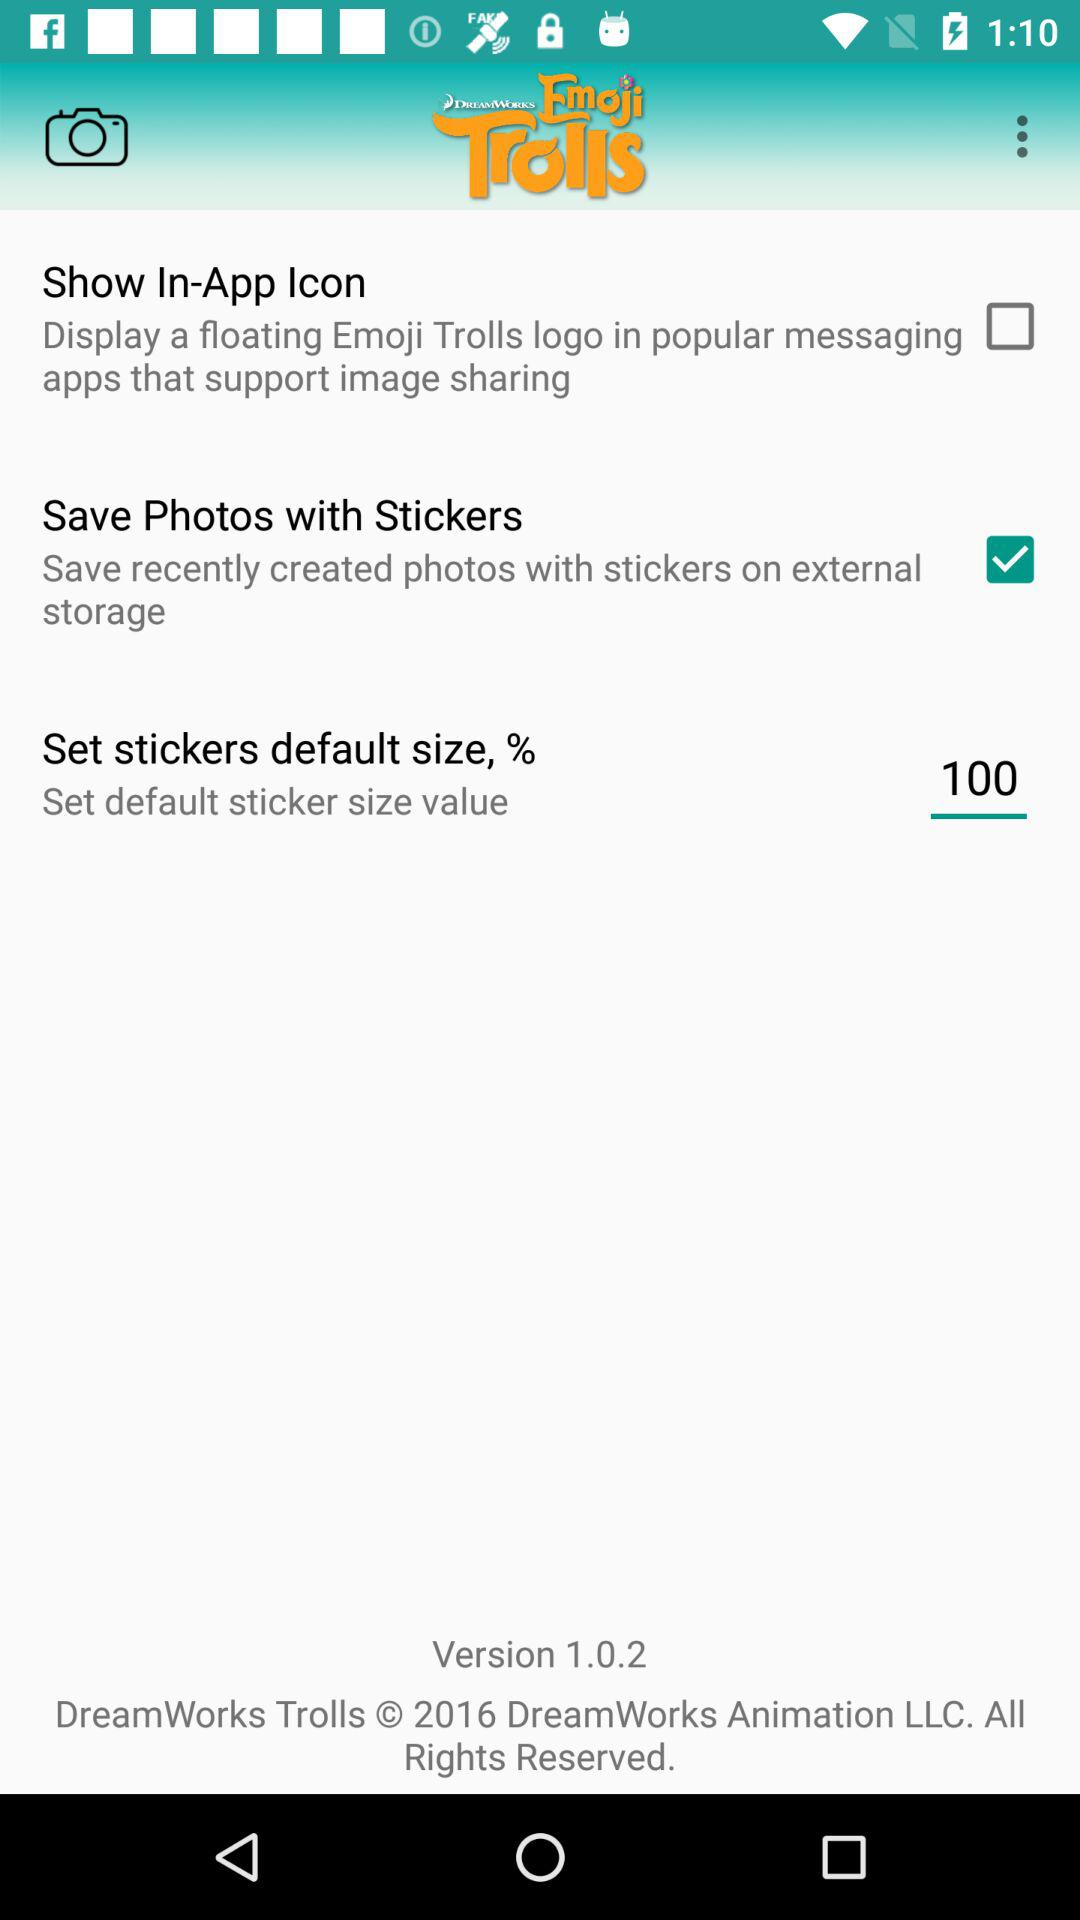What's the version? The version is 1.0.2. 